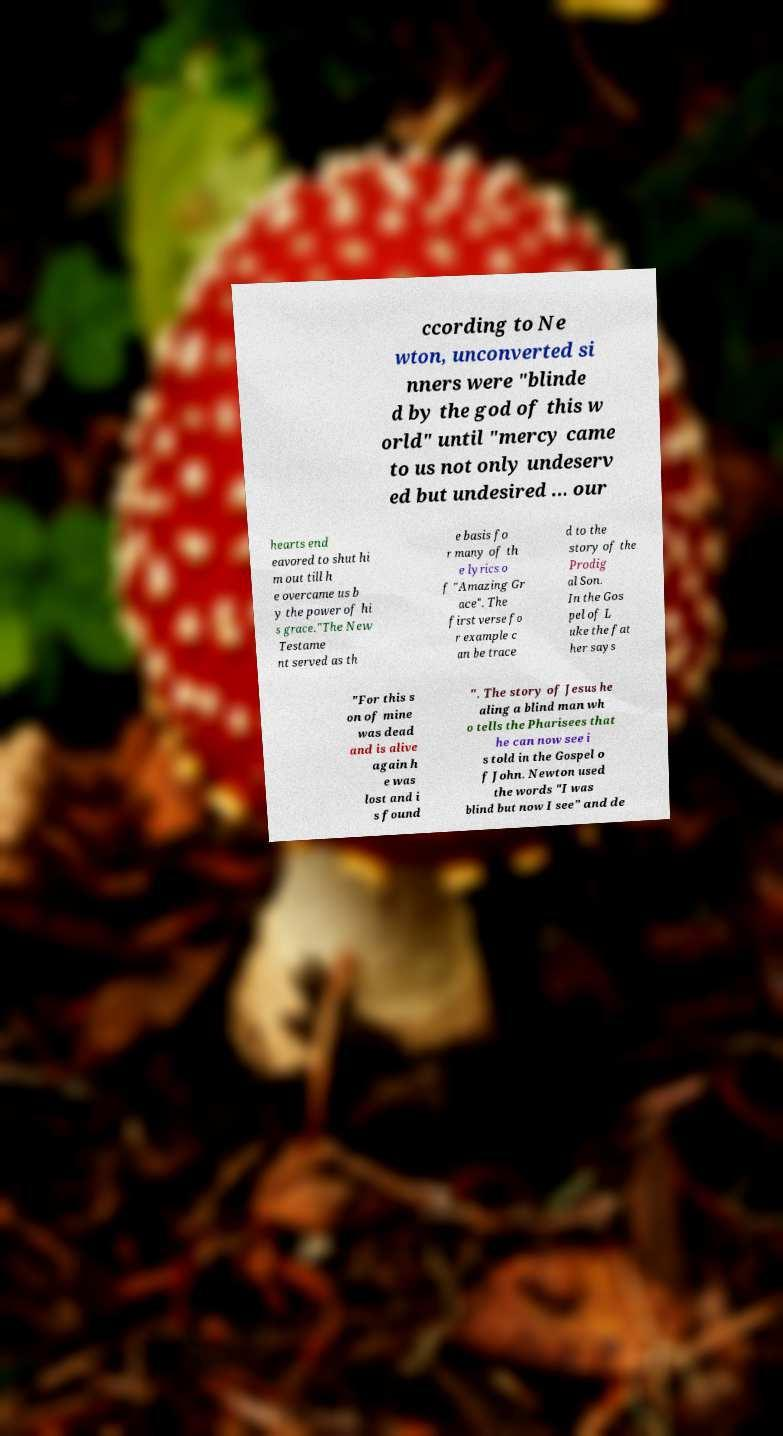What messages or text are displayed in this image? I need them in a readable, typed format. ccording to Ne wton, unconverted si nners were "blinde d by the god of this w orld" until "mercy came to us not only undeserv ed but undesired ... our hearts end eavored to shut hi m out till h e overcame us b y the power of hi s grace."The New Testame nt served as th e basis fo r many of th e lyrics o f "Amazing Gr ace". The first verse fo r example c an be trace d to the story of the Prodig al Son. In the Gos pel of L uke the fat her says "For this s on of mine was dead and is alive again h e was lost and i s found ". The story of Jesus he aling a blind man wh o tells the Pharisees that he can now see i s told in the Gospel o f John. Newton used the words "I was blind but now I see" and de 